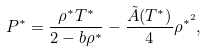<formula> <loc_0><loc_0><loc_500><loc_500>P ^ { * } = \frac { \rho ^ { * } T ^ { * } } { 2 - b \rho ^ { * } } - \frac { \tilde { A } ( T ^ { * } ) } { 4 } \rho ^ { * ^ { 2 } } ,</formula> 